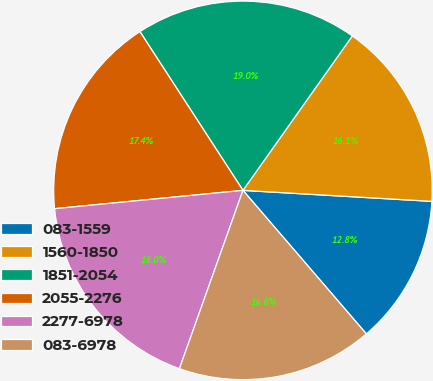Convert chart to OTSL. <chart><loc_0><loc_0><loc_500><loc_500><pie_chart><fcel>083-1559<fcel>1560-1850<fcel>1851-2054<fcel>2055-2276<fcel>2277-6978<fcel>083-6978<nl><fcel>12.77%<fcel>16.12%<fcel>18.97%<fcel>17.38%<fcel>18.01%<fcel>16.75%<nl></chart> 